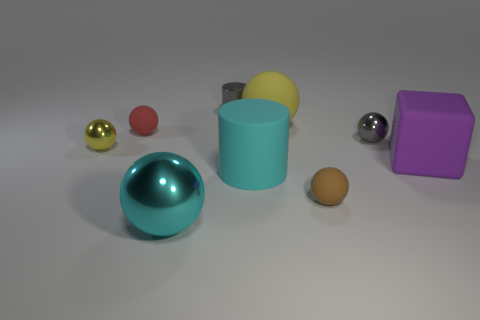There is a brown rubber sphere that is in front of the big cyan thing on the right side of the gray cylinder; is there a small brown thing that is in front of it?
Provide a succinct answer. No. What is the shape of the tiny red object?
Ensure brevity in your answer.  Sphere. Are there fewer cyan matte things that are right of the tiny brown matte ball than big gray metal cylinders?
Your response must be concise. No. Is there a cyan thing of the same shape as the tiny yellow metallic thing?
Your answer should be compact. Yes. There is a yellow rubber thing that is the same size as the matte cube; what shape is it?
Offer a very short reply. Sphere. How many things are yellow shiny cylinders or matte things?
Offer a terse response. 5. Are any gray metal objects visible?
Keep it short and to the point. Yes. Is the number of big green matte cylinders less than the number of metal balls?
Make the answer very short. Yes. Is there a rubber cylinder that has the same size as the cyan metallic object?
Your response must be concise. Yes. Is the shape of the small yellow metal object the same as the small object that is in front of the large purple cube?
Give a very brief answer. Yes. 